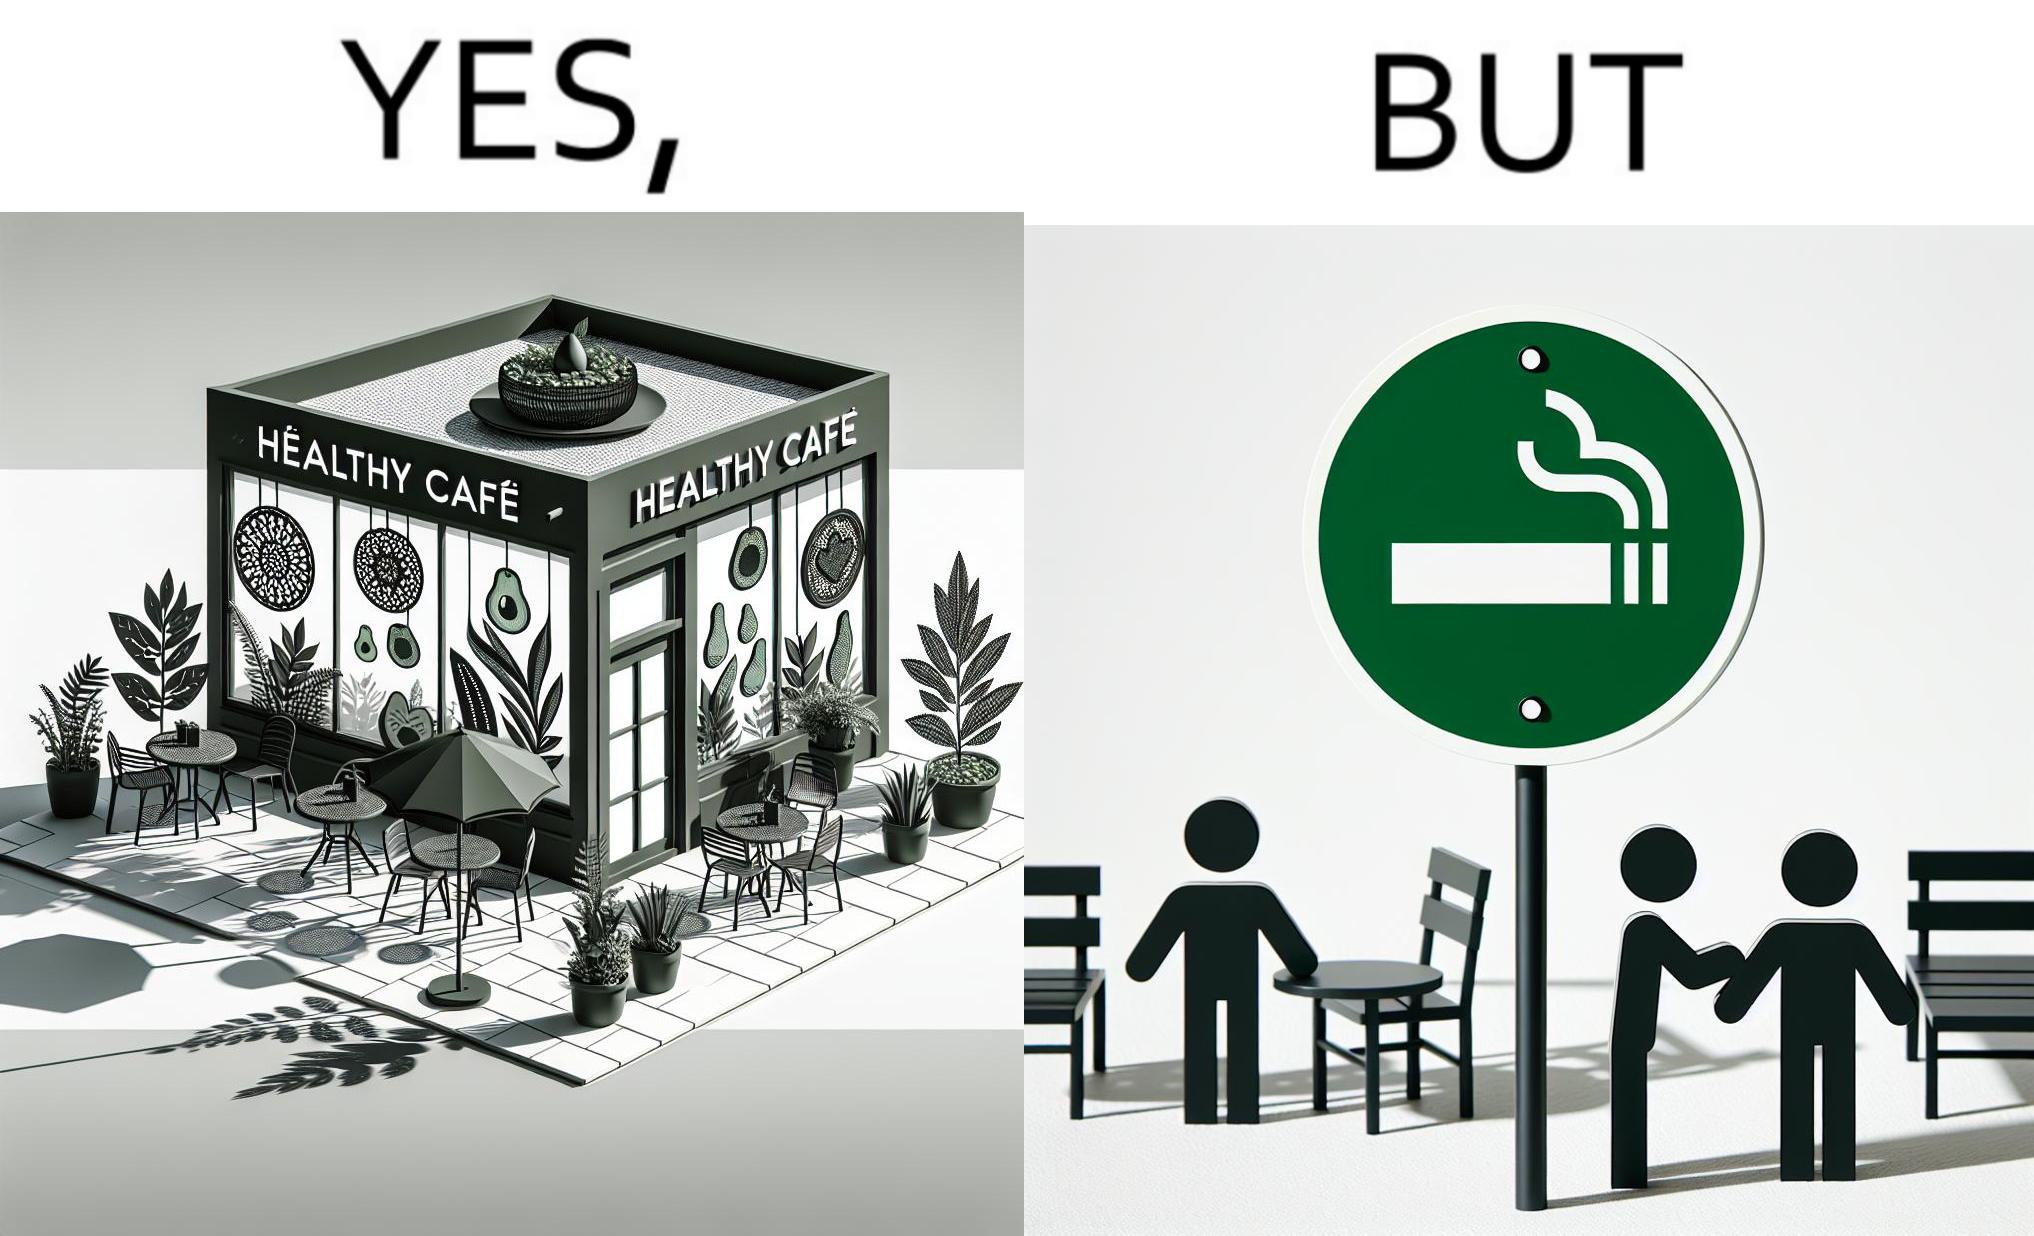Is there satirical content in this image? Yes, this image is satirical. 